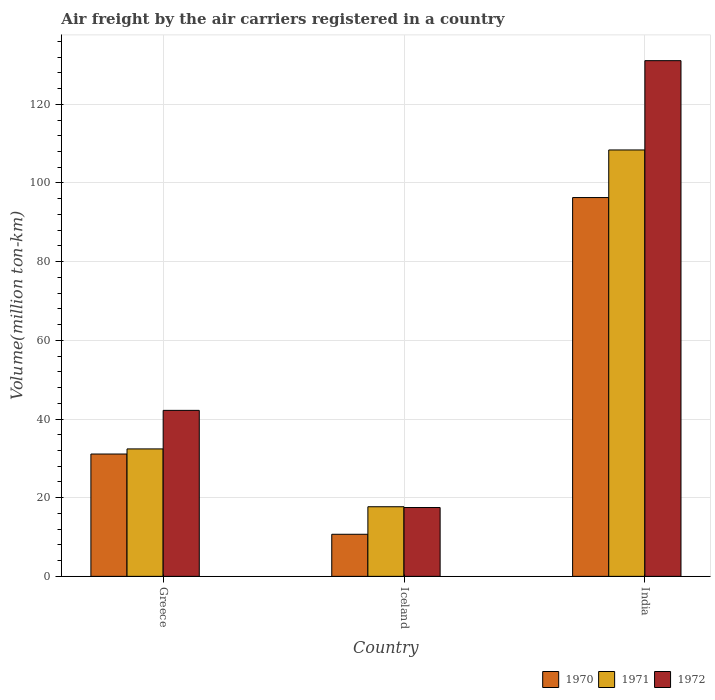How many groups of bars are there?
Provide a short and direct response. 3. Are the number of bars per tick equal to the number of legend labels?
Offer a very short reply. Yes. Are the number of bars on each tick of the X-axis equal?
Offer a very short reply. Yes. What is the label of the 1st group of bars from the left?
Provide a short and direct response. Greece. What is the volume of the air carriers in 1970 in India?
Provide a succinct answer. 96.3. Across all countries, what is the maximum volume of the air carriers in 1970?
Your answer should be very brief. 96.3. Across all countries, what is the minimum volume of the air carriers in 1970?
Your answer should be compact. 10.7. In which country was the volume of the air carriers in 1972 maximum?
Offer a very short reply. India. In which country was the volume of the air carriers in 1972 minimum?
Your response must be concise. Iceland. What is the total volume of the air carriers in 1970 in the graph?
Make the answer very short. 138.1. What is the difference between the volume of the air carriers in 1970 in Greece and that in Iceland?
Ensure brevity in your answer.  20.4. What is the difference between the volume of the air carriers in 1970 in India and the volume of the air carriers in 1971 in Greece?
Your response must be concise. 63.9. What is the average volume of the air carriers in 1971 per country?
Your answer should be very brief. 52.83. What is the difference between the volume of the air carriers of/in 1970 and volume of the air carriers of/in 1972 in India?
Provide a succinct answer. -34.8. What is the ratio of the volume of the air carriers in 1972 in Iceland to that in India?
Ensure brevity in your answer.  0.13. Is the volume of the air carriers in 1972 in Iceland less than that in India?
Provide a short and direct response. Yes. Is the difference between the volume of the air carriers in 1970 in Greece and Iceland greater than the difference between the volume of the air carriers in 1972 in Greece and Iceland?
Give a very brief answer. No. What is the difference between the highest and the second highest volume of the air carriers in 1971?
Ensure brevity in your answer.  14.7. What is the difference between the highest and the lowest volume of the air carriers in 1970?
Provide a succinct answer. 85.6. In how many countries, is the volume of the air carriers in 1970 greater than the average volume of the air carriers in 1970 taken over all countries?
Your answer should be compact. 1. Is the sum of the volume of the air carriers in 1972 in Iceland and India greater than the maximum volume of the air carriers in 1970 across all countries?
Offer a very short reply. Yes. What does the 2nd bar from the right in Greece represents?
Your answer should be very brief. 1971. Is it the case that in every country, the sum of the volume of the air carriers in 1972 and volume of the air carriers in 1970 is greater than the volume of the air carriers in 1971?
Give a very brief answer. Yes. How many bars are there?
Keep it short and to the point. 9. Are all the bars in the graph horizontal?
Provide a succinct answer. No. How many countries are there in the graph?
Provide a short and direct response. 3. What is the title of the graph?
Keep it short and to the point. Air freight by the air carriers registered in a country. Does "1973" appear as one of the legend labels in the graph?
Keep it short and to the point. No. What is the label or title of the X-axis?
Your response must be concise. Country. What is the label or title of the Y-axis?
Offer a terse response. Volume(million ton-km). What is the Volume(million ton-km) of 1970 in Greece?
Offer a terse response. 31.1. What is the Volume(million ton-km) of 1971 in Greece?
Your answer should be compact. 32.4. What is the Volume(million ton-km) of 1972 in Greece?
Ensure brevity in your answer.  42.2. What is the Volume(million ton-km) of 1970 in Iceland?
Your answer should be very brief. 10.7. What is the Volume(million ton-km) of 1971 in Iceland?
Keep it short and to the point. 17.7. What is the Volume(million ton-km) of 1970 in India?
Make the answer very short. 96.3. What is the Volume(million ton-km) in 1971 in India?
Offer a terse response. 108.4. What is the Volume(million ton-km) of 1972 in India?
Make the answer very short. 131.1. Across all countries, what is the maximum Volume(million ton-km) in 1970?
Give a very brief answer. 96.3. Across all countries, what is the maximum Volume(million ton-km) of 1971?
Offer a very short reply. 108.4. Across all countries, what is the maximum Volume(million ton-km) of 1972?
Keep it short and to the point. 131.1. Across all countries, what is the minimum Volume(million ton-km) in 1970?
Your response must be concise. 10.7. Across all countries, what is the minimum Volume(million ton-km) of 1971?
Ensure brevity in your answer.  17.7. What is the total Volume(million ton-km) in 1970 in the graph?
Keep it short and to the point. 138.1. What is the total Volume(million ton-km) of 1971 in the graph?
Make the answer very short. 158.5. What is the total Volume(million ton-km) of 1972 in the graph?
Your answer should be very brief. 190.8. What is the difference between the Volume(million ton-km) in 1970 in Greece and that in Iceland?
Your answer should be compact. 20.4. What is the difference between the Volume(million ton-km) of 1971 in Greece and that in Iceland?
Provide a short and direct response. 14.7. What is the difference between the Volume(million ton-km) in 1972 in Greece and that in Iceland?
Give a very brief answer. 24.7. What is the difference between the Volume(million ton-km) in 1970 in Greece and that in India?
Your answer should be compact. -65.2. What is the difference between the Volume(million ton-km) in 1971 in Greece and that in India?
Your answer should be compact. -76. What is the difference between the Volume(million ton-km) in 1972 in Greece and that in India?
Give a very brief answer. -88.9. What is the difference between the Volume(million ton-km) of 1970 in Iceland and that in India?
Provide a short and direct response. -85.6. What is the difference between the Volume(million ton-km) in 1971 in Iceland and that in India?
Provide a short and direct response. -90.7. What is the difference between the Volume(million ton-km) in 1972 in Iceland and that in India?
Make the answer very short. -113.6. What is the difference between the Volume(million ton-km) in 1970 in Greece and the Volume(million ton-km) in 1972 in Iceland?
Keep it short and to the point. 13.6. What is the difference between the Volume(million ton-km) of 1970 in Greece and the Volume(million ton-km) of 1971 in India?
Your response must be concise. -77.3. What is the difference between the Volume(million ton-km) of 1970 in Greece and the Volume(million ton-km) of 1972 in India?
Provide a short and direct response. -100. What is the difference between the Volume(million ton-km) of 1971 in Greece and the Volume(million ton-km) of 1972 in India?
Your answer should be very brief. -98.7. What is the difference between the Volume(million ton-km) in 1970 in Iceland and the Volume(million ton-km) in 1971 in India?
Give a very brief answer. -97.7. What is the difference between the Volume(million ton-km) of 1970 in Iceland and the Volume(million ton-km) of 1972 in India?
Your answer should be very brief. -120.4. What is the difference between the Volume(million ton-km) of 1971 in Iceland and the Volume(million ton-km) of 1972 in India?
Offer a very short reply. -113.4. What is the average Volume(million ton-km) in 1970 per country?
Keep it short and to the point. 46.03. What is the average Volume(million ton-km) in 1971 per country?
Offer a terse response. 52.83. What is the average Volume(million ton-km) in 1972 per country?
Your answer should be very brief. 63.6. What is the difference between the Volume(million ton-km) in 1971 and Volume(million ton-km) in 1972 in Greece?
Your answer should be compact. -9.8. What is the difference between the Volume(million ton-km) in 1970 and Volume(million ton-km) in 1971 in Iceland?
Offer a very short reply. -7. What is the difference between the Volume(million ton-km) of 1970 and Volume(million ton-km) of 1972 in Iceland?
Your answer should be compact. -6.8. What is the difference between the Volume(million ton-km) of 1970 and Volume(million ton-km) of 1972 in India?
Your answer should be very brief. -34.8. What is the difference between the Volume(million ton-km) in 1971 and Volume(million ton-km) in 1972 in India?
Provide a succinct answer. -22.7. What is the ratio of the Volume(million ton-km) in 1970 in Greece to that in Iceland?
Make the answer very short. 2.91. What is the ratio of the Volume(million ton-km) in 1971 in Greece to that in Iceland?
Keep it short and to the point. 1.83. What is the ratio of the Volume(million ton-km) of 1972 in Greece to that in Iceland?
Ensure brevity in your answer.  2.41. What is the ratio of the Volume(million ton-km) in 1970 in Greece to that in India?
Ensure brevity in your answer.  0.32. What is the ratio of the Volume(million ton-km) of 1971 in Greece to that in India?
Your answer should be compact. 0.3. What is the ratio of the Volume(million ton-km) of 1972 in Greece to that in India?
Keep it short and to the point. 0.32. What is the ratio of the Volume(million ton-km) of 1970 in Iceland to that in India?
Your response must be concise. 0.11. What is the ratio of the Volume(million ton-km) in 1971 in Iceland to that in India?
Your answer should be very brief. 0.16. What is the ratio of the Volume(million ton-km) in 1972 in Iceland to that in India?
Give a very brief answer. 0.13. What is the difference between the highest and the second highest Volume(million ton-km) of 1970?
Make the answer very short. 65.2. What is the difference between the highest and the second highest Volume(million ton-km) of 1972?
Keep it short and to the point. 88.9. What is the difference between the highest and the lowest Volume(million ton-km) of 1970?
Provide a succinct answer. 85.6. What is the difference between the highest and the lowest Volume(million ton-km) in 1971?
Your answer should be very brief. 90.7. What is the difference between the highest and the lowest Volume(million ton-km) of 1972?
Ensure brevity in your answer.  113.6. 